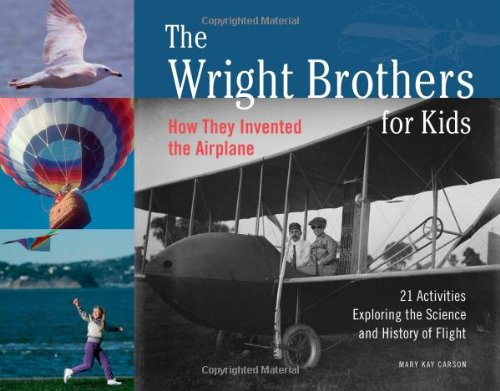What is the title of this book? The title of the book is 'The Wright Brothers for Kids: How They Invented the Airplane, 21 Activities Exploring the Science and History of Flight (For Kids series)', which delves into the fascinating story of aviation pioneers and includes interactive activities aimed at children. 